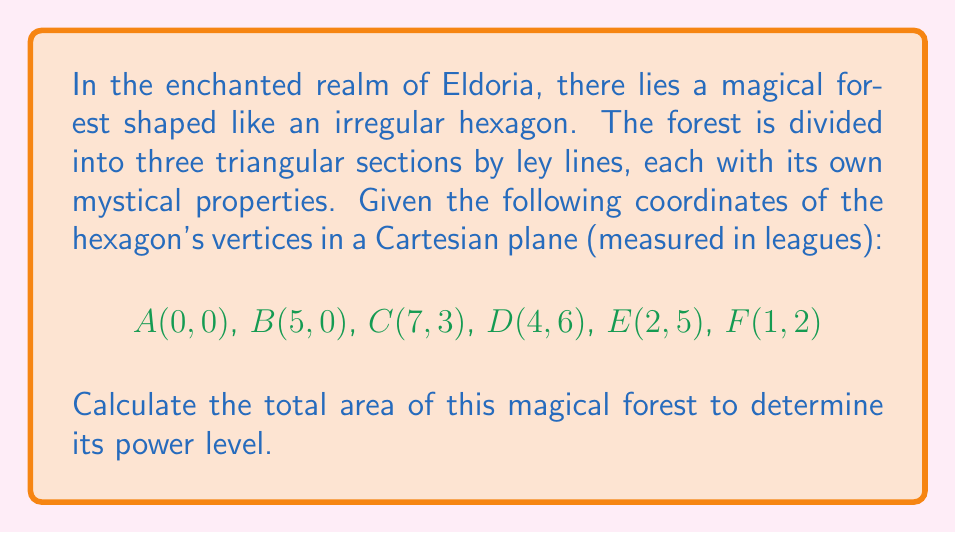Provide a solution to this math problem. To solve this problem, we'll use the following steps:

1) First, we'll divide the hexagon into three triangles: ABC, ACD, and ADE.

2) We'll use the formula for the area of a triangle given the coordinates of its vertices:
   Area = $\frac{1}{2}|x_1(y_2 - y_3) + x_2(y_3 - y_1) + x_3(y_1 - y_2)|$

3) For triangle ABC:
   $Area_{ABC} = \frac{1}{2}|0(0-3) + 5(3-0) + 7(0-0)| = \frac{1}{2}|0 + 15 + 0| = 7.5$

4) For triangle ACD:
   $Area_{ACD} = \frac{1}{2}|0(6-0) + 7(0-6) + 4(0-6)| = \frac{1}{2}|0 - 42 - 24| = 33$

5) For triangle ADE:
   $Area_{ADE} = \frac{1}{2}|0(5-6) + 4(6-5) + 2(5-6)| = \frac{1}{2}|-0 + 4 - 2| = 1$

6) The total area is the sum of these three triangles:
   $Area_{total} = 7.5 + 33 + 1 = 41.5$

[asy]
unitsize(15);
pair A=(0,0), B=(5,0), C=(7,3), D=(4,6), E=(2,5), F=(1,2);
draw(A--B--C--D--E--F--cycle);
draw(A--C--D);
label("A", A, SW);
label("B", B, S);
label("C", C, SE);
label("D", D, N);
label("E", E, NW);
label("F", F, W);
[/asy]
Answer: 41.5 square leagues 